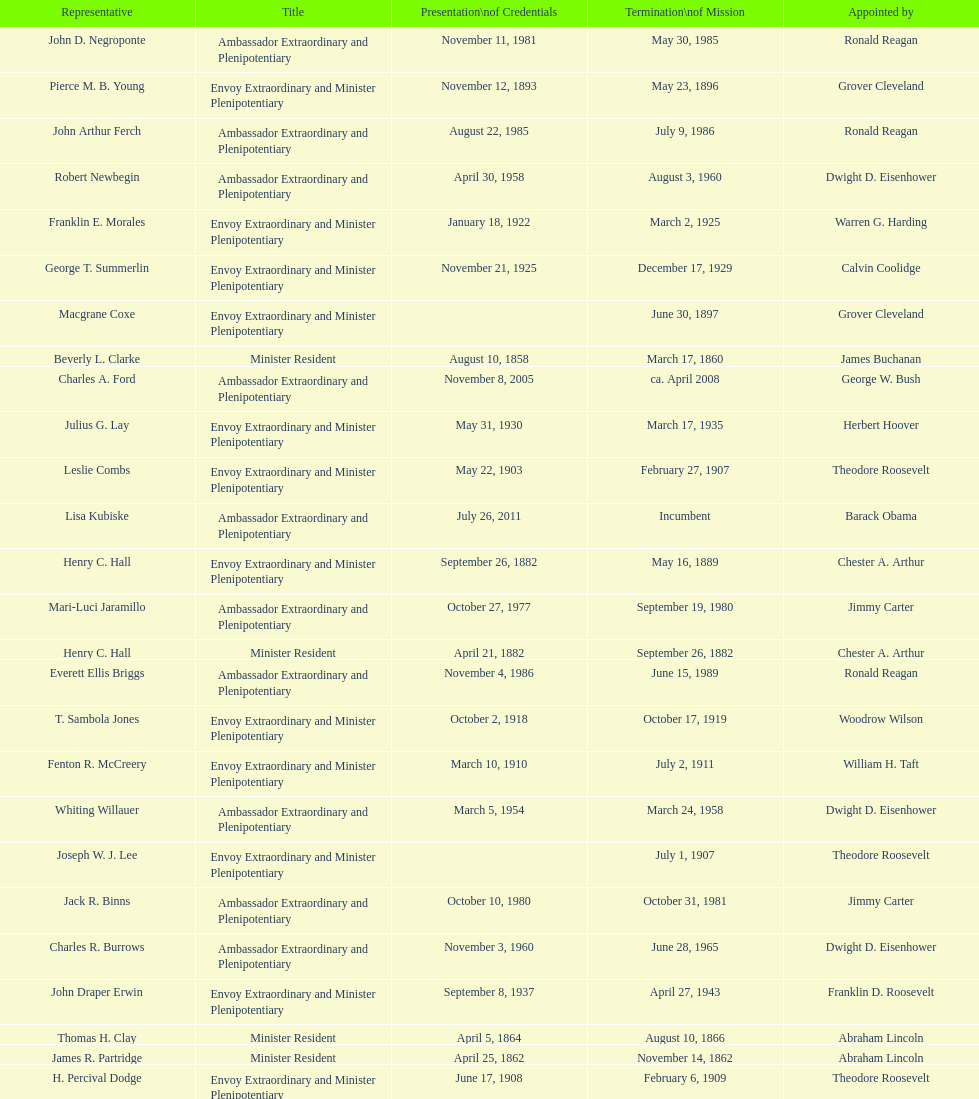How many representatives were appointed by theodore roosevelt? 4. 